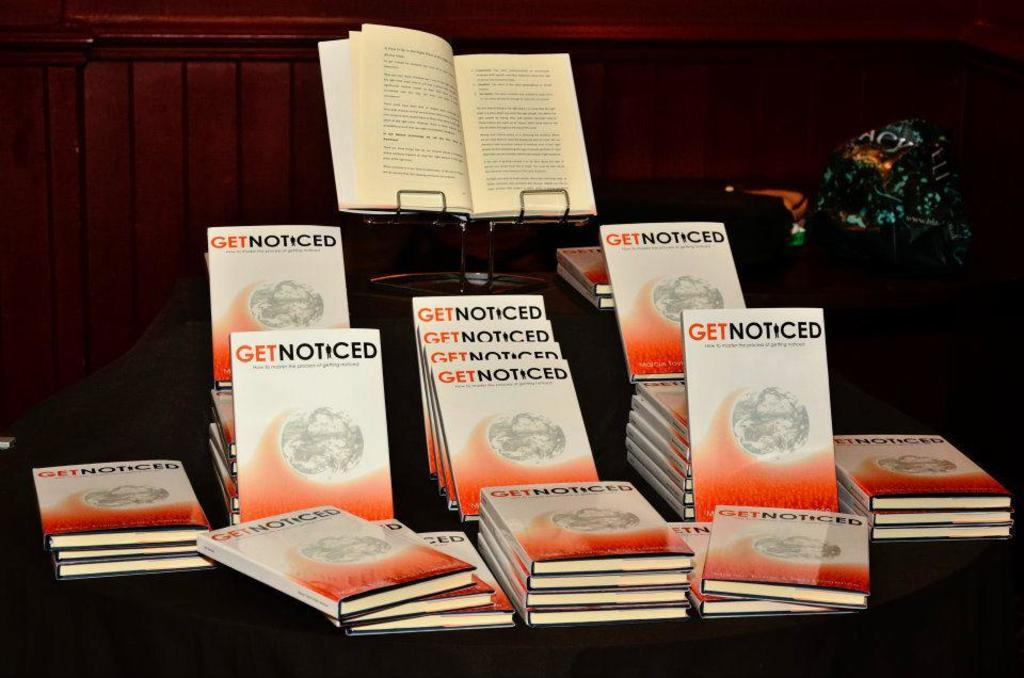<image>
Render a clear and concise summary of the photo. A table with pamphlets on it that say Get Noticed. 